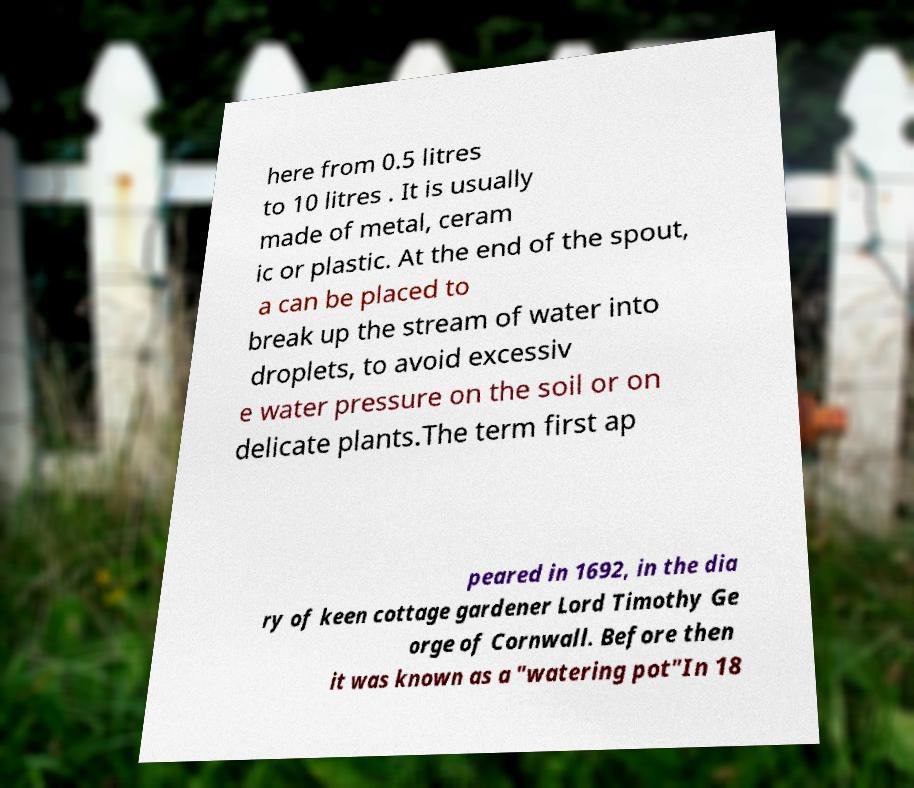Please read and relay the text visible in this image. What does it say? here from 0.5 litres to 10 litres . It is usually made of metal, ceram ic or plastic. At the end of the spout, a can be placed to break up the stream of water into droplets, to avoid excessiv e water pressure on the soil or on delicate plants.The term first ap peared in 1692, in the dia ry of keen cottage gardener Lord Timothy Ge orge of Cornwall. Before then it was known as a "watering pot"In 18 